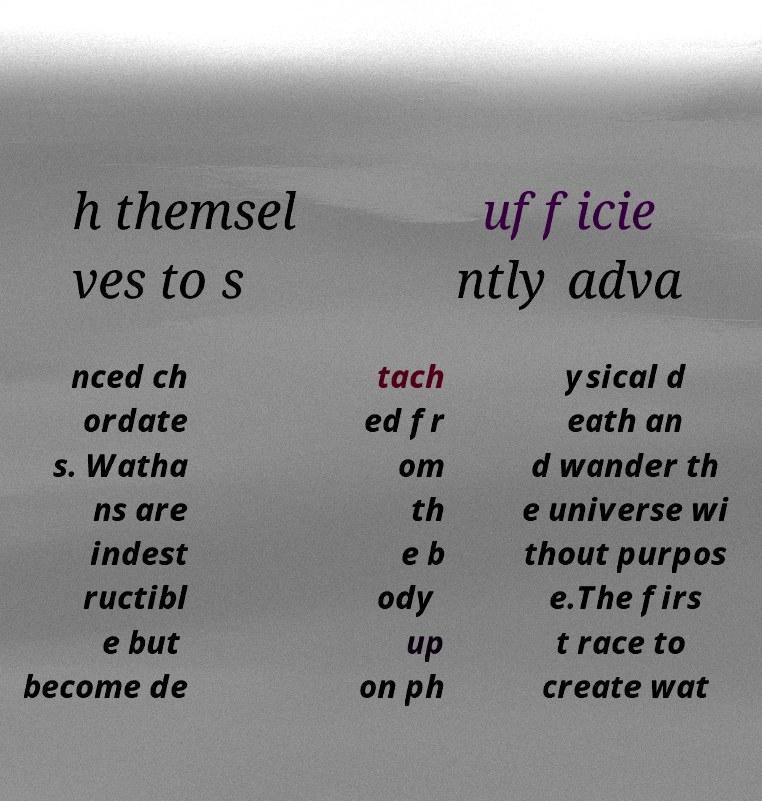There's text embedded in this image that I need extracted. Can you transcribe it verbatim? h themsel ves to s ufficie ntly adva nced ch ordate s. Watha ns are indest ructibl e but become de tach ed fr om th e b ody up on ph ysical d eath an d wander th e universe wi thout purpos e.The firs t race to create wat 